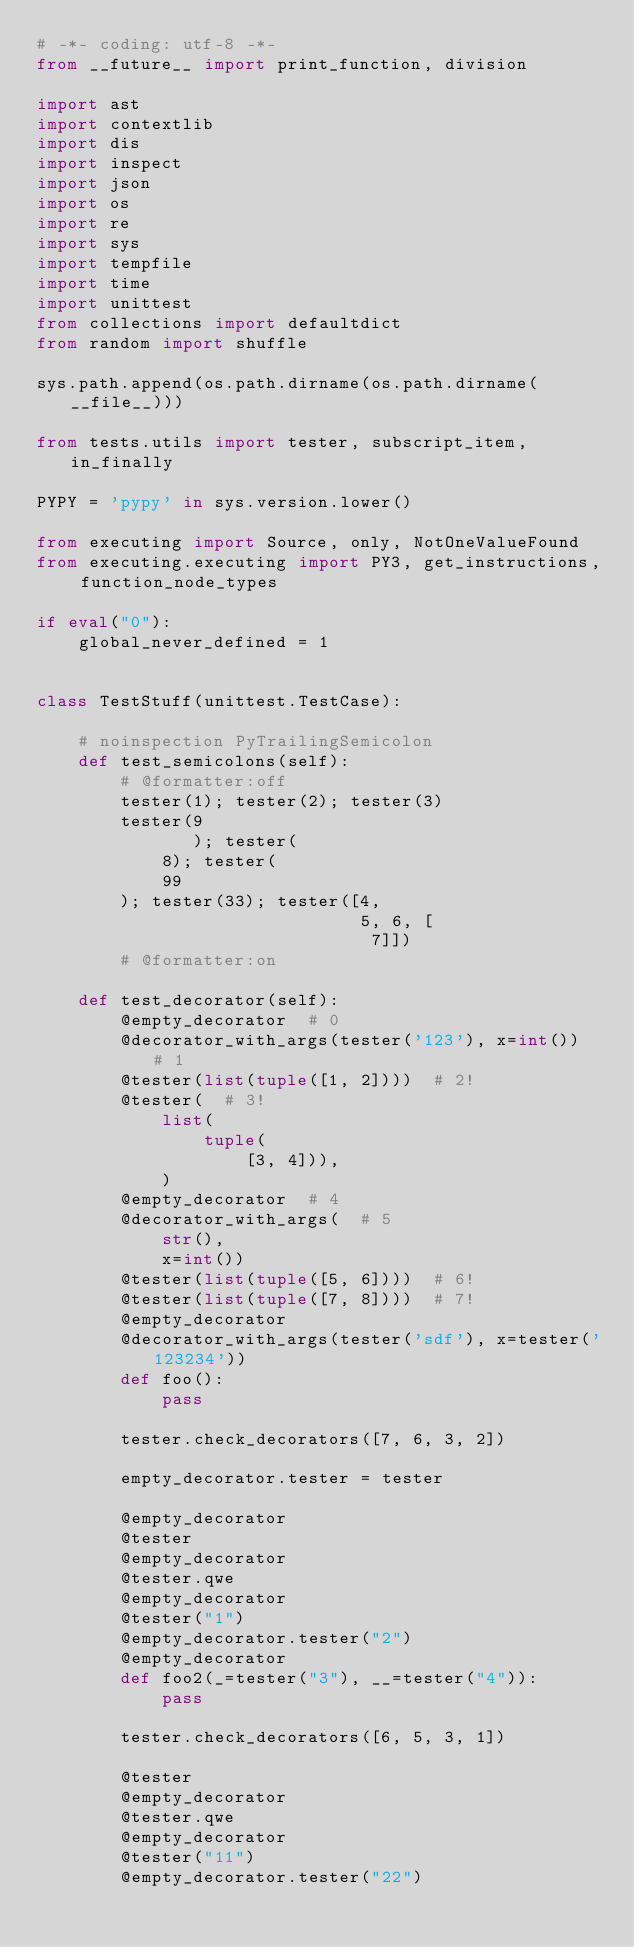Convert code to text. <code><loc_0><loc_0><loc_500><loc_500><_Python_># -*- coding: utf-8 -*-
from __future__ import print_function, division

import ast
import contextlib
import dis
import inspect
import json
import os
import re
import sys
import tempfile
import time
import unittest
from collections import defaultdict
from random import shuffle

sys.path.append(os.path.dirname(os.path.dirname(__file__)))

from tests.utils import tester, subscript_item, in_finally

PYPY = 'pypy' in sys.version.lower()

from executing import Source, only, NotOneValueFound
from executing.executing import PY3, get_instructions, function_node_types

if eval("0"):
    global_never_defined = 1


class TestStuff(unittest.TestCase):

    # noinspection PyTrailingSemicolon
    def test_semicolons(self):
        # @formatter:off
        tester(1); tester(2); tester(3)
        tester(9
               ); tester(
            8); tester(
            99
        ); tester(33); tester([4,
                               5, 6, [
                                7]])
        # @formatter:on

    def test_decorator(self):
        @empty_decorator  # 0
        @decorator_with_args(tester('123'), x=int())  # 1
        @tester(list(tuple([1, 2])))  # 2!
        @tester(  # 3!
            list(
                tuple(
                    [3, 4])),
            )
        @empty_decorator  # 4
        @decorator_with_args(  # 5
            str(),
            x=int())
        @tester(list(tuple([5, 6])))  # 6!
        @tester(list(tuple([7, 8])))  # 7!
        @empty_decorator
        @decorator_with_args(tester('sdf'), x=tester('123234'))
        def foo():
            pass

        tester.check_decorators([7, 6, 3, 2])

        empty_decorator.tester = tester

        @empty_decorator
        @tester
        @empty_decorator
        @tester.qwe
        @empty_decorator
        @tester("1")
        @empty_decorator.tester("2")
        @empty_decorator
        def foo2(_=tester("3"), __=tester("4")):
            pass

        tester.check_decorators([6, 5, 3, 1])

        @tester
        @empty_decorator
        @tester.qwe
        @empty_decorator
        @tester("11")
        @empty_decorator.tester("22")</code> 